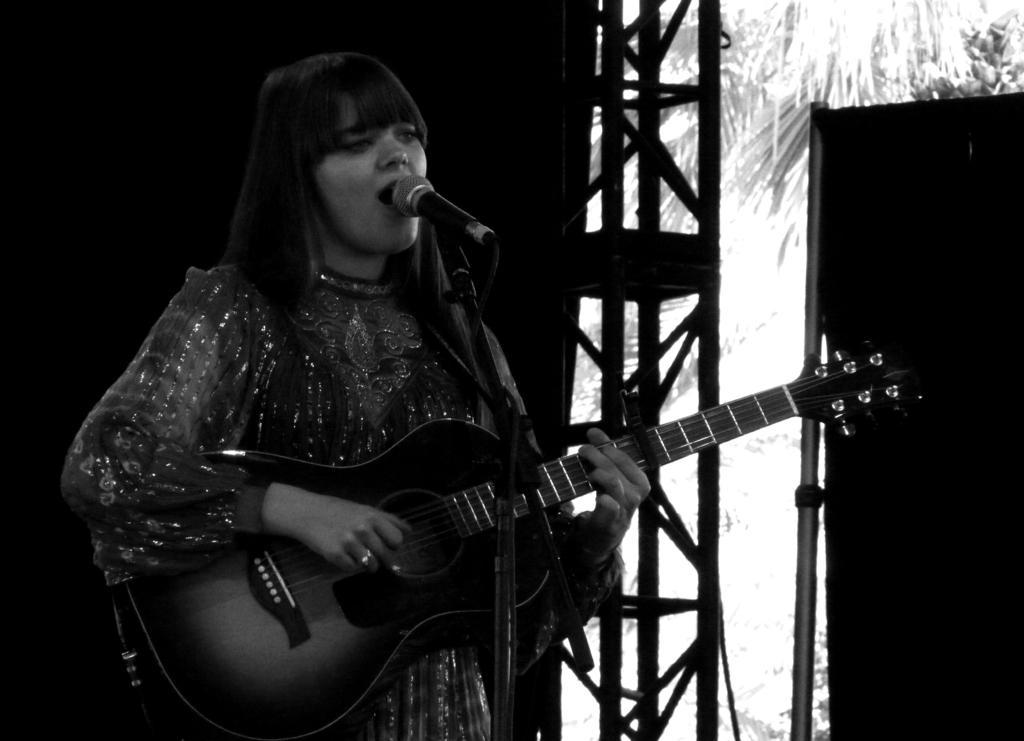Please provide a concise description of this image. In the center woman is standing in this picture singing in front of the mic holding a musical instrument in her hand. In the background there are trees, stand and a black colour sheet. 